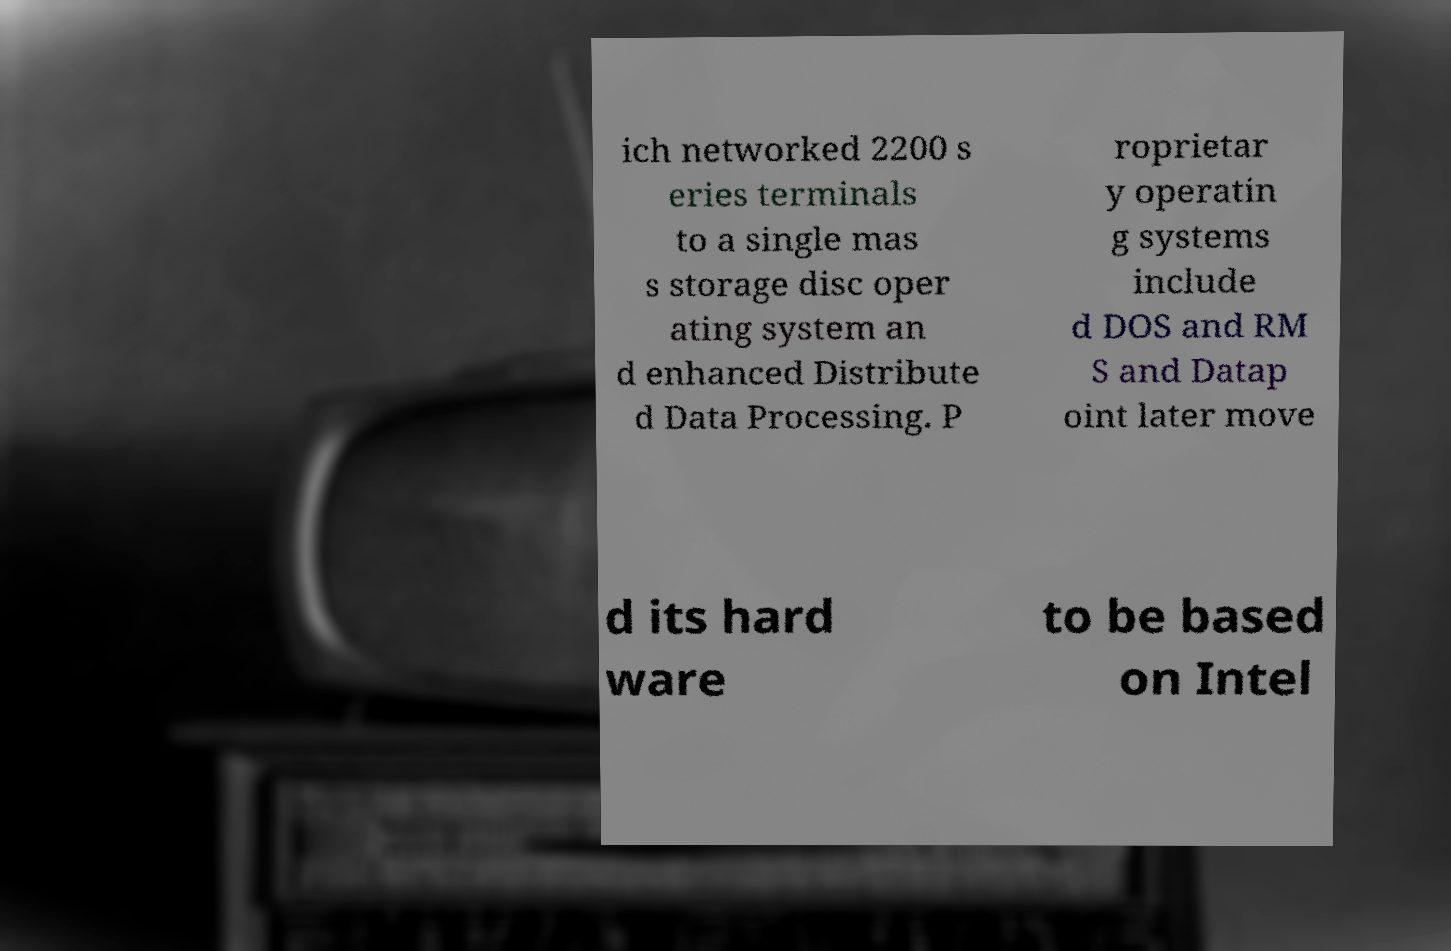I need the written content from this picture converted into text. Can you do that? ich networked 2200 s eries terminals to a single mas s storage disc oper ating system an d enhanced Distribute d Data Processing. P roprietar y operatin g systems include d DOS and RM S and Datap oint later move d its hard ware to be based on Intel 